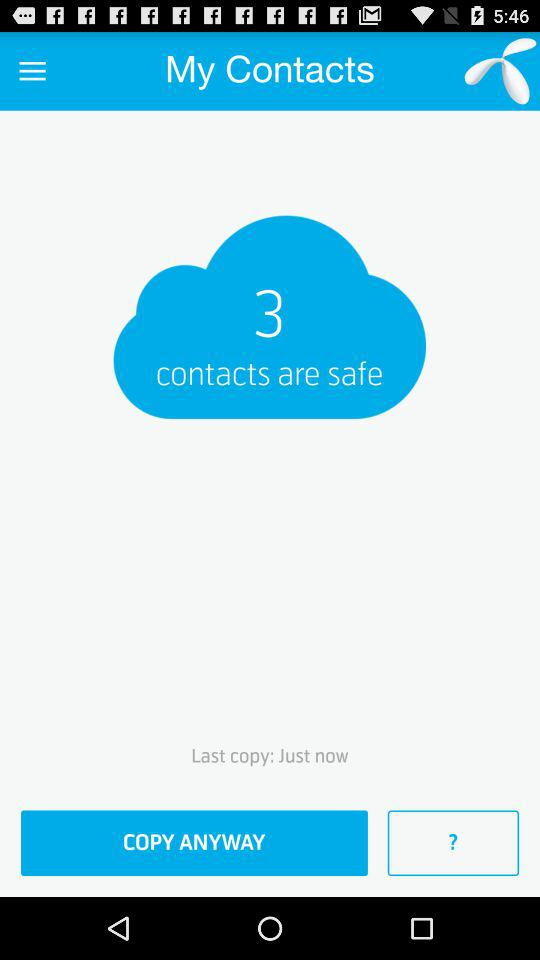How many contacts are on the cloud?
Answer the question using a single word or phrase. 3 